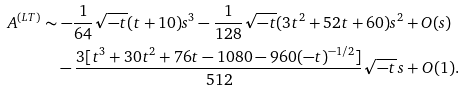Convert formula to latex. <formula><loc_0><loc_0><loc_500><loc_500>A ^ { ( L T ) } & \sim - \frac { 1 } { 6 4 } \sqrt { - t } ( t + 1 0 ) s ^ { 3 } - \frac { 1 } { 1 2 8 } \sqrt { - t } ( 3 t ^ { 2 } + 5 2 t + 6 0 ) s ^ { 2 } + O ( s ) \\ & \quad - \frac { 3 [ t ^ { 3 } + 3 0 t ^ { 2 } + 7 6 t - 1 0 8 0 - 9 6 0 ( - t ) ^ { - 1 / 2 } ] } { 5 1 2 } \sqrt { - t } \, s + O ( 1 ) .</formula> 